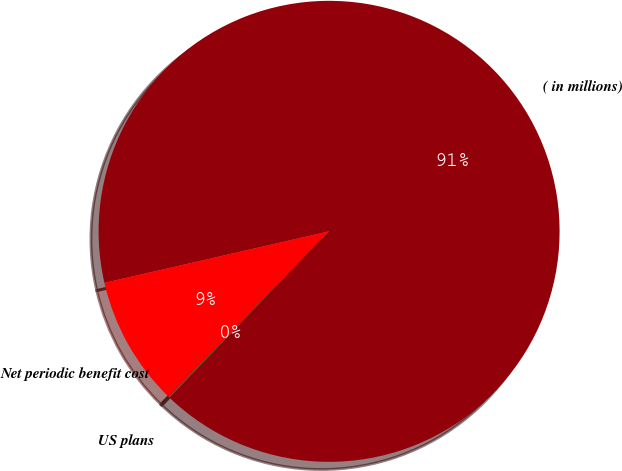Convert chart. <chart><loc_0><loc_0><loc_500><loc_500><pie_chart><fcel>( in millions)<fcel>US plans<fcel>Net periodic benefit cost<nl><fcel>90.78%<fcel>0.08%<fcel>9.15%<nl></chart> 